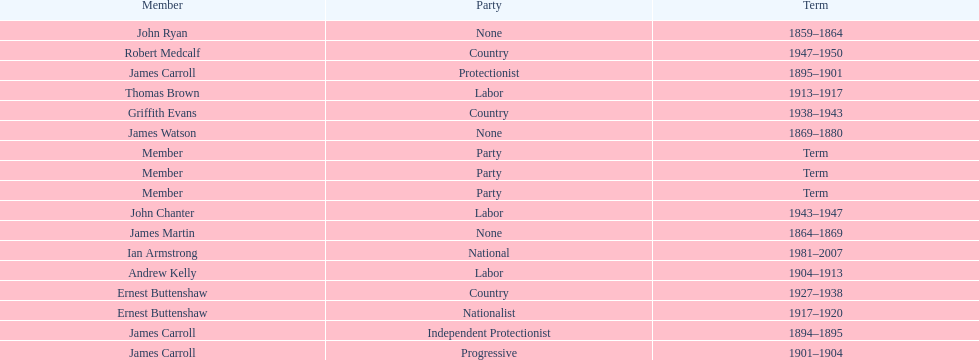I'm looking to parse the entire table for insights. Could you assist me with that? {'header': ['Member', 'Party', 'Term'], 'rows': [['John Ryan', 'None', '1859–1864'], ['Robert Medcalf', 'Country', '1947–1950'], ['James Carroll', 'Protectionist', '1895–1901'], ['Thomas Brown', 'Labor', '1913–1917'], ['Griffith Evans', 'Country', '1938–1943'], ['James Watson', 'None', '1869–1880'], ['Member', 'Party', 'Term'], ['Member', 'Party', 'Term'], ['Member', 'Party', 'Term'], ['John Chanter', 'Labor', '1943–1947'], ['James Martin', 'None', '1864–1869'], ['Ian Armstrong', 'National', '1981–2007'], ['Andrew Kelly', 'Labor', '1904–1913'], ['Ernest Buttenshaw', 'Country', '1927–1938'], ['Ernest Buttenshaw', 'Nationalist', '1917–1920'], ['James Carroll', 'Independent Protectionist', '1894–1895'], ['James Carroll', 'Progressive', '1901–1904']]} How many years of service do the members of the second incarnation have combined? 26. 